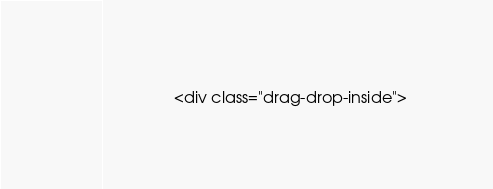Convert code to text. <code><loc_0><loc_0><loc_500><loc_500><_PHP_>				<div class="drag-drop-inside"></code> 